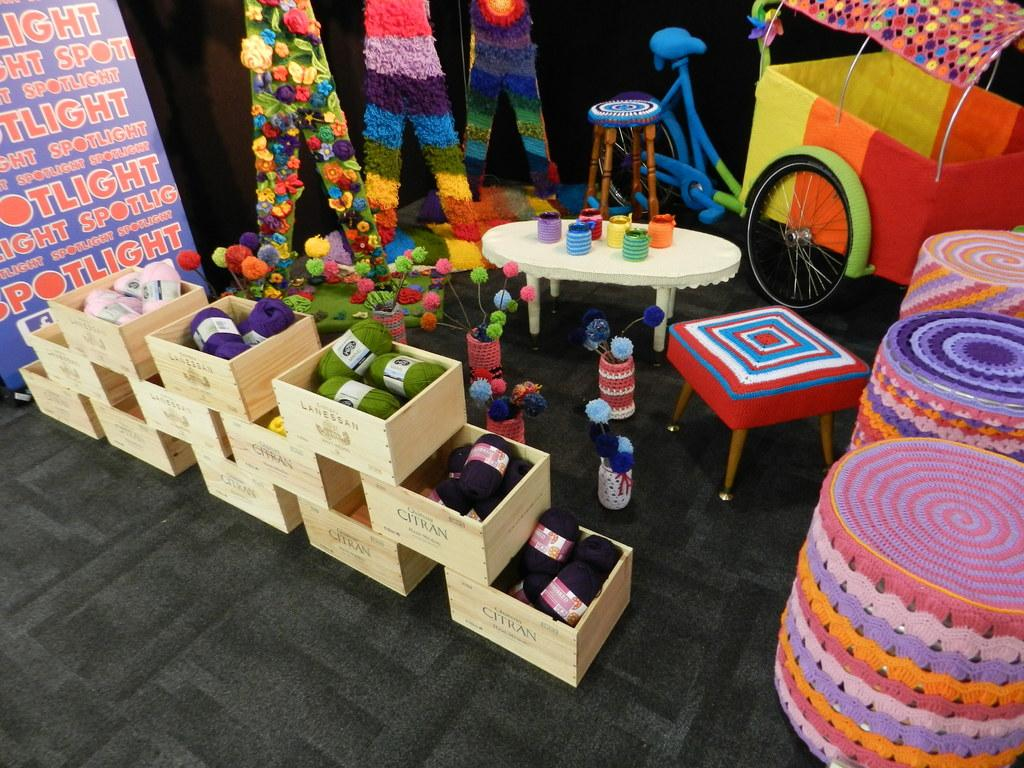What objects are on the floor in the image? There are boxes on the floor in the image. What type of furniture is present in the image? There is a chair and a table in the image. What mode of transportation can be seen in the image? There is a bicycle in the image. What is hanging or attached to a surface in the image? There is a banner in the image. What type of canvas is being used to create a rhythm in the image? There is no canvas or rhythm present in the image. 